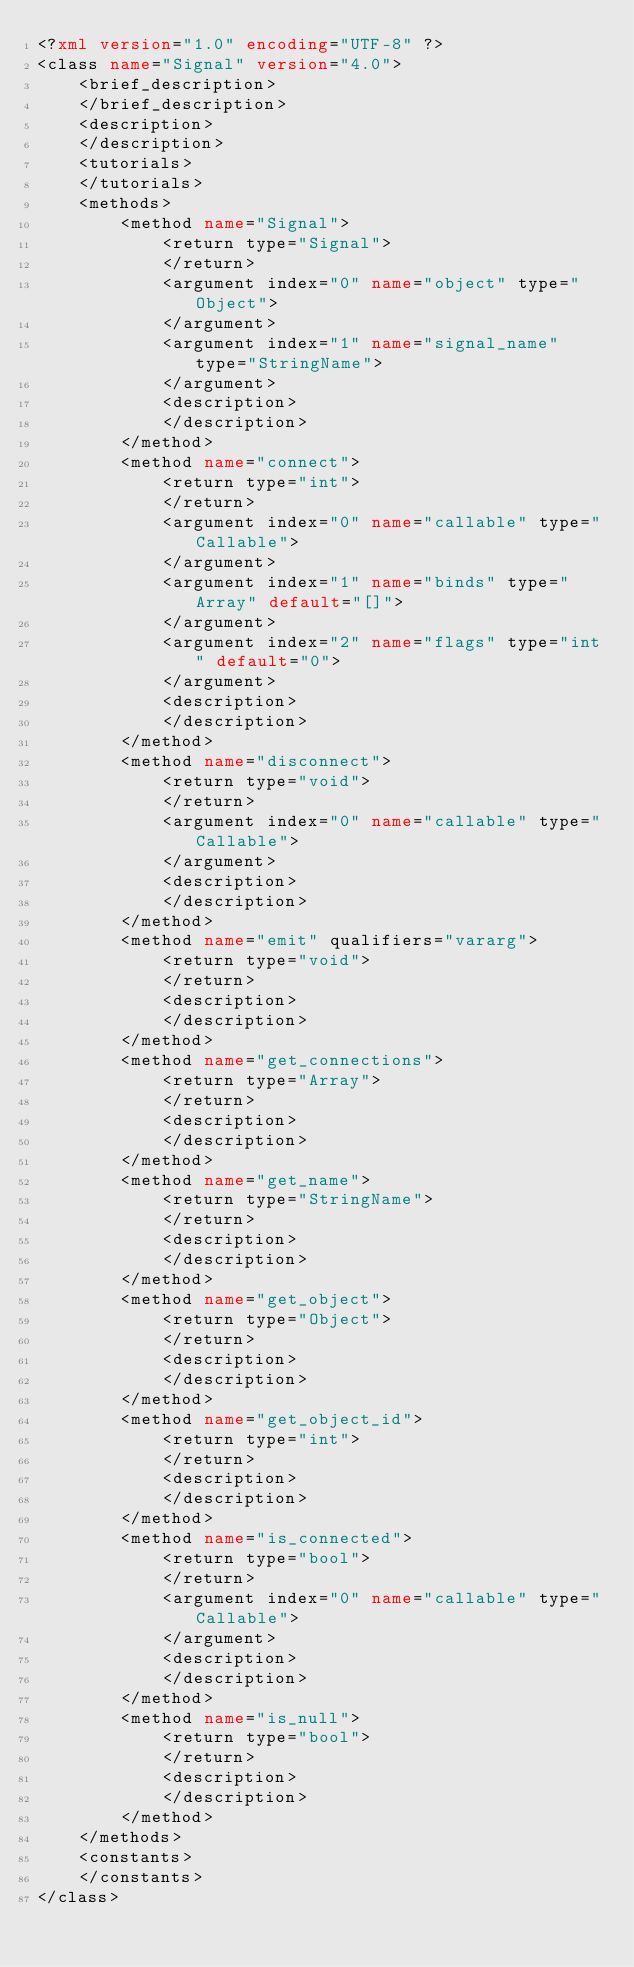Convert code to text. <code><loc_0><loc_0><loc_500><loc_500><_XML_><?xml version="1.0" encoding="UTF-8" ?>
<class name="Signal" version="4.0">
	<brief_description>
	</brief_description>
	<description>
	</description>
	<tutorials>
	</tutorials>
	<methods>
		<method name="Signal">
			<return type="Signal">
			</return>
			<argument index="0" name="object" type="Object">
			</argument>
			<argument index="1" name="signal_name" type="StringName">
			</argument>
			<description>
			</description>
		</method>
		<method name="connect">
			<return type="int">
			</return>
			<argument index="0" name="callable" type="Callable">
			</argument>
			<argument index="1" name="binds" type="Array" default="[]">
			</argument>
			<argument index="2" name="flags" type="int" default="0">
			</argument>
			<description>
			</description>
		</method>
		<method name="disconnect">
			<return type="void">
			</return>
			<argument index="0" name="callable" type="Callable">
			</argument>
			<description>
			</description>
		</method>
		<method name="emit" qualifiers="vararg">
			<return type="void">
			</return>
			<description>
			</description>
		</method>
		<method name="get_connections">
			<return type="Array">
			</return>
			<description>
			</description>
		</method>
		<method name="get_name">
			<return type="StringName">
			</return>
			<description>
			</description>
		</method>
		<method name="get_object">
			<return type="Object">
			</return>
			<description>
			</description>
		</method>
		<method name="get_object_id">
			<return type="int">
			</return>
			<description>
			</description>
		</method>
		<method name="is_connected">
			<return type="bool">
			</return>
			<argument index="0" name="callable" type="Callable">
			</argument>
			<description>
			</description>
		</method>
		<method name="is_null">
			<return type="bool">
			</return>
			<description>
			</description>
		</method>
	</methods>
	<constants>
	</constants>
</class>
</code> 